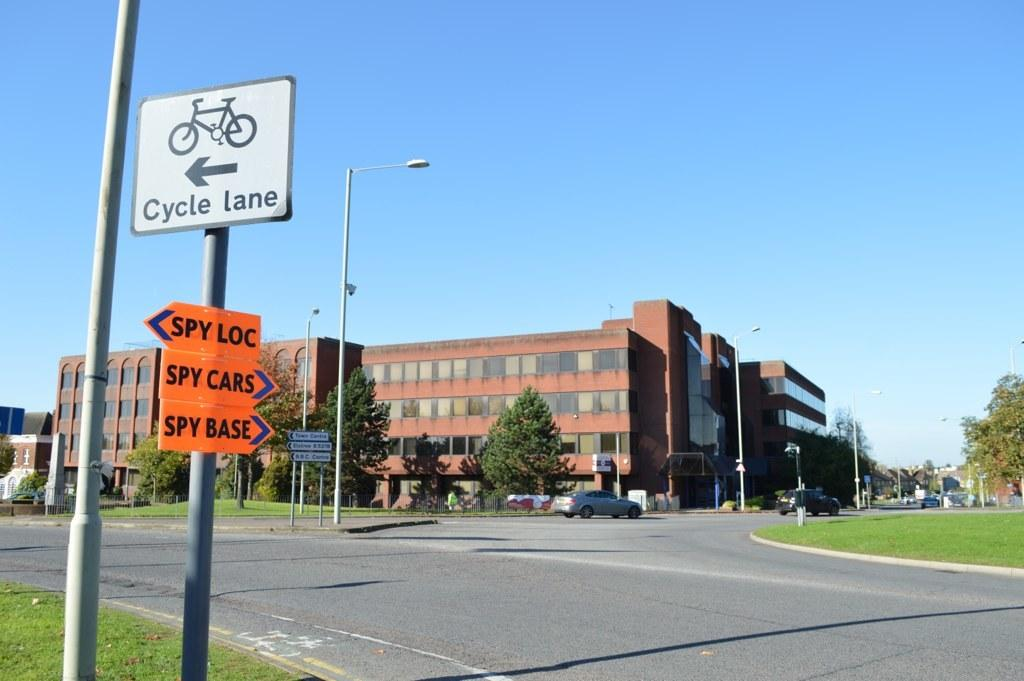What objects can be seen in the image? There are boards, vehicles, and streetlights visible in the image. What can be seen in the background of the image? There are buildings, trees, and the sky visible in the background of the image. What type of structures are present in the background? There are buildings in the background of the image. What is the purpose of the streetlights in the image? The streetlights are likely for illuminating the road at night. What type of grain can be seen growing in the garden in the image? There is no garden or grain present in the image. What sound can be heard coming from the vehicles in the image? The image is static, so no sound can be heard from the vehicles. 